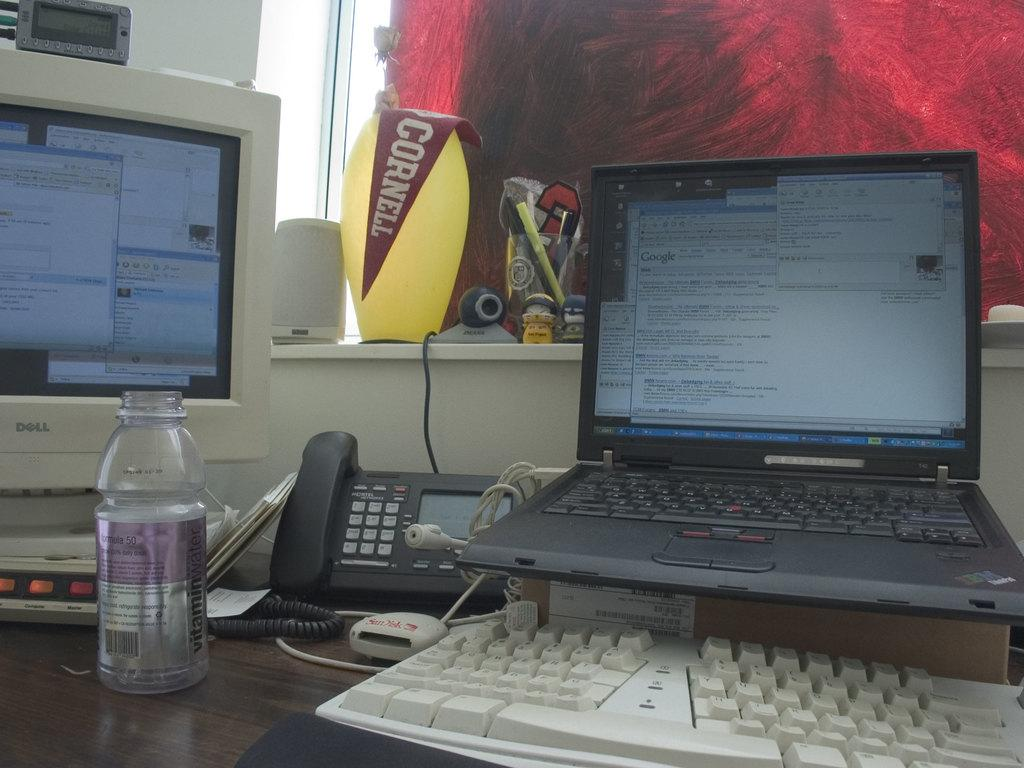What type of electronic device is present in the image? There is a computer and a laptop in the image. What is used for typing in the image? There is a keyboard in the image. What type of phone is present in the image? There is a land phone in the image. What is the container for holding a liquid in the image? There is a bottle in the image. What is used for storing writing instruments in the image? There is a pen stand in the image. What is the source of light in the image? There is a light in the image. What is used for amplifying sound in the image? There is a speaker in the image. What type of fiction is the person reading in the image? There is no person or book present in the image, so it is not possible to determine what type of fiction might be read. 